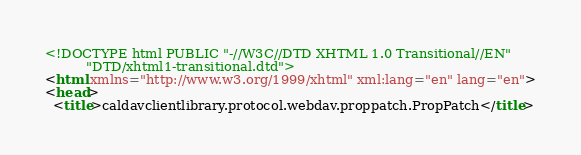Convert code to text. <code><loc_0><loc_0><loc_500><loc_500><_HTML_><!DOCTYPE html PUBLIC "-//W3C//DTD XHTML 1.0 Transitional//EN"
          "DTD/xhtml1-transitional.dtd">
<html xmlns="http://www.w3.org/1999/xhtml" xml:lang="en" lang="en">
<head>
  <title>caldavclientlibrary.protocol.webdav.proppatch.PropPatch</title></code> 